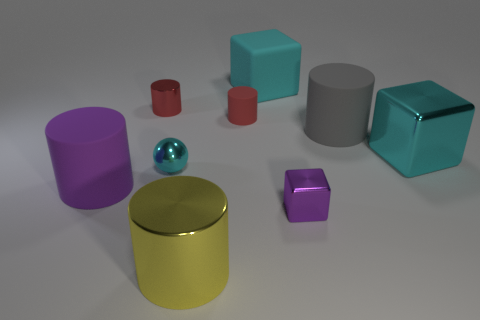Subtract all small blocks. How many blocks are left? 2 Subtract 2 cubes. How many cubes are left? 1 Subtract all cyan cubes. How many cubes are left? 1 Subtract all spheres. How many objects are left? 8 Subtract all red cylinders. Subtract all blue cubes. How many cylinders are left? 3 Subtract all blue balls. How many purple cylinders are left? 1 Subtract all small purple metallic blocks. Subtract all shiny cubes. How many objects are left? 6 Add 5 big rubber things. How many big rubber things are left? 8 Add 7 cyan cubes. How many cyan cubes exist? 9 Subtract 1 cyan balls. How many objects are left? 8 